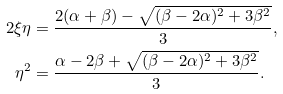<formula> <loc_0><loc_0><loc_500><loc_500>2 \xi \eta & = \frac { 2 ( \alpha + \beta ) - \sqrt { ( \beta - 2 \alpha ) ^ { 2 } + 3 \beta ^ { 2 } } } { 3 } , \\ \eta ^ { 2 } & = \frac { \alpha - 2 \beta + \sqrt { ( \beta - 2 \alpha ) ^ { 2 } + 3 \beta ^ { 2 } } } { 3 } .</formula> 